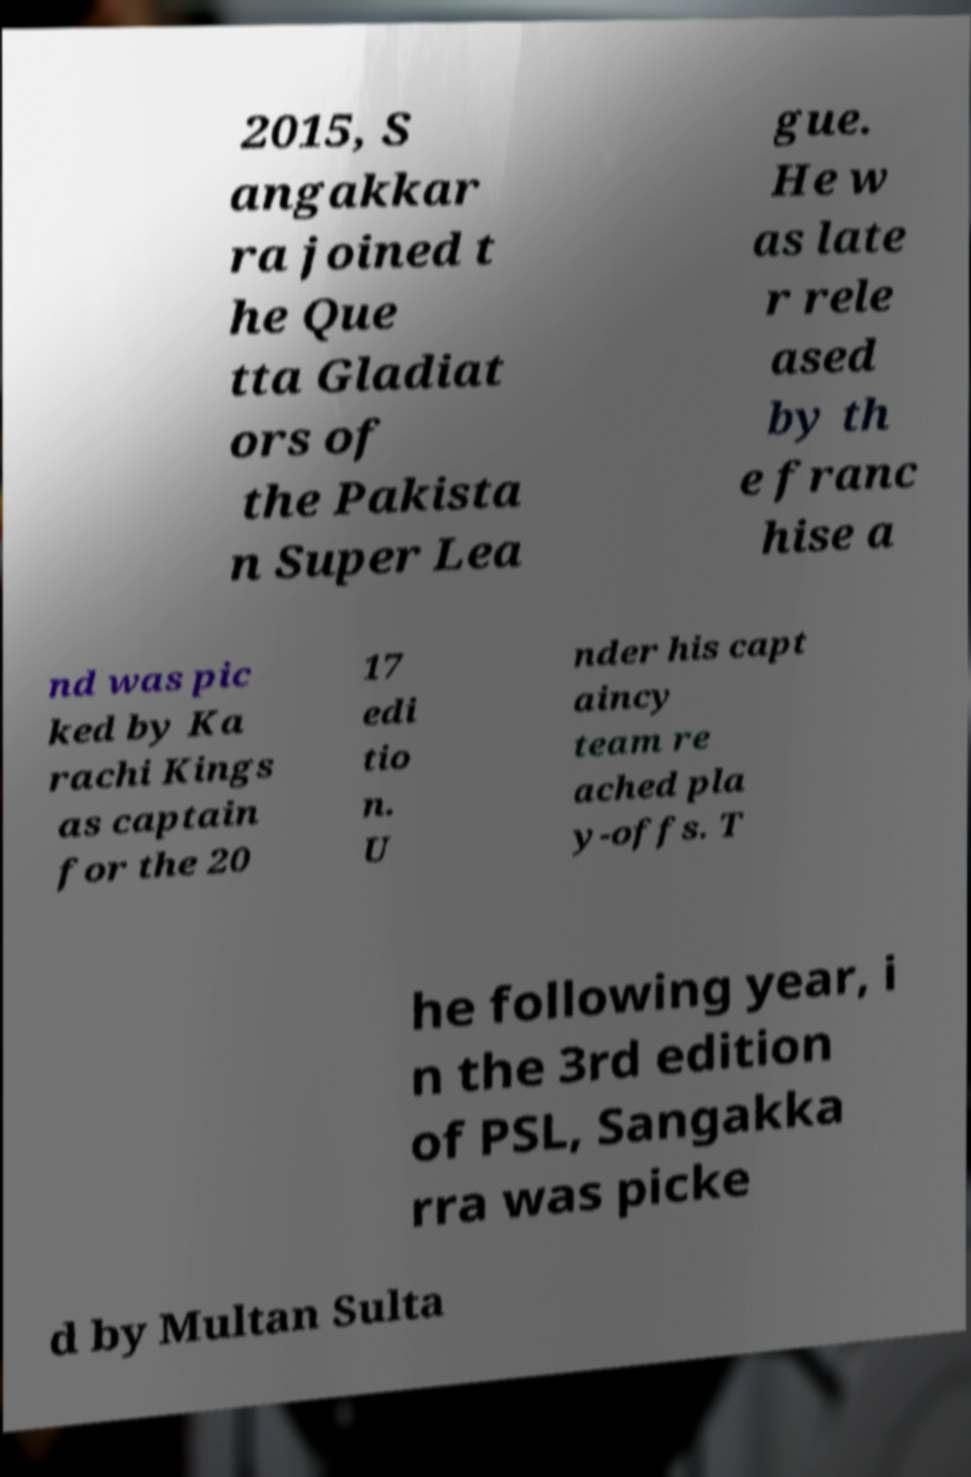For documentation purposes, I need the text within this image transcribed. Could you provide that? 2015, S angakkar ra joined t he Que tta Gladiat ors of the Pakista n Super Lea gue. He w as late r rele ased by th e franc hise a nd was pic ked by Ka rachi Kings as captain for the 20 17 edi tio n. U nder his capt aincy team re ached pla y-offs. T he following year, i n the 3rd edition of PSL, Sangakka rra was picke d by Multan Sulta 